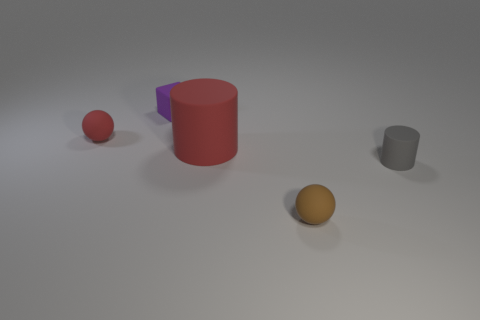Are the thing that is to the right of the brown ball and the large red thing made of the same material?
Offer a very short reply. Yes. There is a red rubber object behind the rubber cylinder that is behind the matte cylinder on the right side of the brown ball; how big is it?
Keep it short and to the point. Small. What number of other objects are the same color as the big matte cylinder?
Ensure brevity in your answer.  1. There is a purple object that is the same size as the brown object; what shape is it?
Provide a succinct answer. Cube. There is a cylinder on the left side of the brown rubber sphere; what is its size?
Your answer should be compact. Large. There is a rubber cylinder that is right of the large cylinder; does it have the same color as the rubber sphere behind the small brown matte thing?
Offer a very short reply. No. There is a tiny ball that is behind the rubber ball that is in front of the ball that is behind the big red object; what is it made of?
Make the answer very short. Rubber. Is there a red thing that has the same size as the purple matte object?
Your answer should be compact. Yes. There is a red ball that is the same size as the purple object; what material is it?
Provide a succinct answer. Rubber. The big red matte thing on the left side of the gray matte thing has what shape?
Your answer should be very brief. Cylinder. 